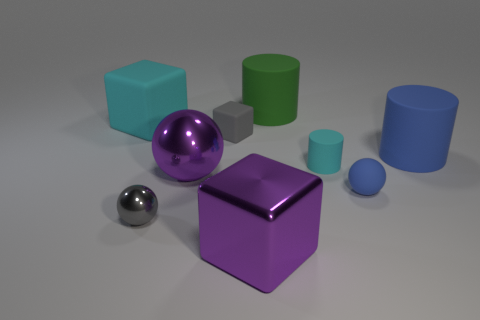Add 1 tiny gray matte things. How many objects exist? 10 Subtract all cylinders. How many objects are left? 6 Add 1 blue matte spheres. How many blue matte spheres are left? 2 Add 5 red balls. How many red balls exist? 5 Subtract 1 gray blocks. How many objects are left? 8 Subtract all purple rubber cubes. Subtract all small shiny objects. How many objects are left? 8 